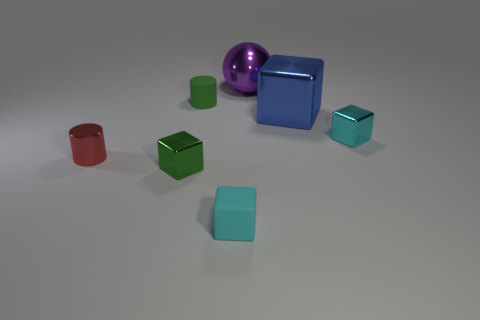What is the material of the green thing that is the same shape as the small red metal object?
Provide a succinct answer. Rubber. What shape is the small green object that is made of the same material as the small red cylinder?
Make the answer very short. Cube. There is a cylinder that is behind the red metallic object; is its size the same as the small green block?
Your response must be concise. Yes. How many things are blocks behind the tiny cyan rubber cube or tiny metal things that are on the left side of the tiny cyan rubber cube?
Provide a succinct answer. 4. There is a tiny metallic thing right of the big sphere; does it have the same color as the tiny matte cube?
Your response must be concise. Yes. What number of matte objects are either tiny green balls or green cylinders?
Keep it short and to the point. 1. The tiny cyan metallic object has what shape?
Keep it short and to the point. Cube. Do the green cube and the big blue block have the same material?
Keep it short and to the point. Yes. There is a tiny green object that is in front of the rubber object that is behind the blue metallic cube; are there any tiny objects that are behind it?
Your response must be concise. Yes. How many other things are there of the same shape as the cyan rubber thing?
Provide a short and direct response. 3. 